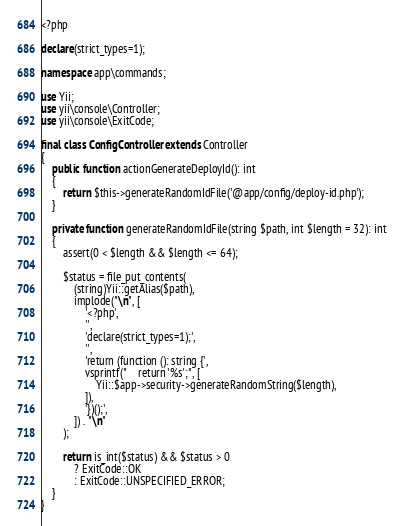Convert code to text. <code><loc_0><loc_0><loc_500><loc_500><_PHP_><?php

declare(strict_types=1);

namespace app\commands;

use Yii;
use yii\console\Controller;
use yii\console\ExitCode;

final class ConfigController extends Controller
{
    public function actionGenerateDeployId(): int
    {
        return $this->generateRandomIdFile('@app/config/deploy-id.php');
    }

    private function generateRandomIdFile(string $path, int $length = 32): int
    {
        assert(0 < $length && $length <= 64);

        $status = file_put_contents(
            (string)Yii::getAlias($path),
            implode("\n", [
                '<?php',
                '',
                'declare(strict_types=1);',
                '',
                'return (function (): string {',
                vsprintf("    return '%s';", [
                    Yii::$app->security->generateRandomString($length),
                ]),
                '})();',
            ]) . "\n"
        );

        return is_int($status) && $status > 0
            ? ExitCode::OK
            : ExitCode::UNSPECIFIED_ERROR;
    }
}
</code> 